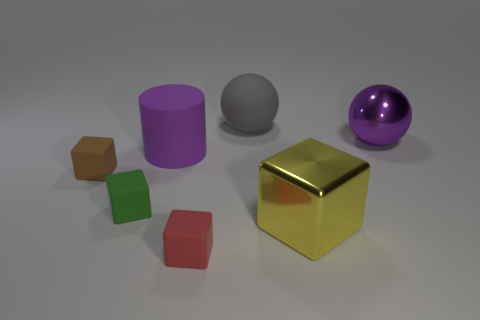Subtract all green blocks. How many blocks are left? 3 Subtract all green blocks. How many blocks are left? 3 Subtract 3 blocks. How many blocks are left? 1 Subtract all blocks. How many objects are left? 3 Subtract all gray spheres. How many yellow cylinders are left? 0 Add 2 shiny spheres. How many objects exist? 9 Subtract all blue balls. Subtract all blue cylinders. How many balls are left? 2 Subtract all cyan metal blocks. Subtract all red matte objects. How many objects are left? 6 Add 4 large purple matte cylinders. How many large purple matte cylinders are left? 5 Add 5 small cubes. How many small cubes exist? 8 